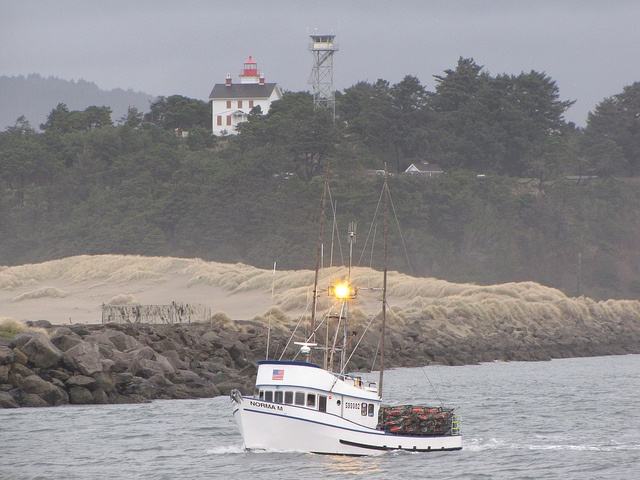Describe the objects in this image and their specific colors. I can see a boat in darkgray, lightgray, gray, and black tones in this image. 